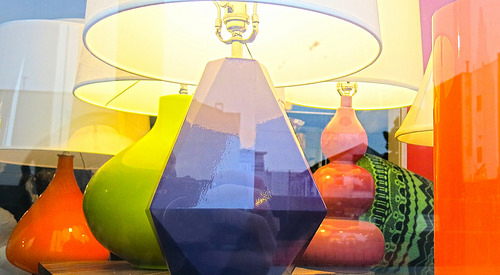<image>
Is the green vase behind the orange vase? Yes. From this viewpoint, the green vase is positioned behind the orange vase, with the orange vase partially or fully occluding the green vase. 